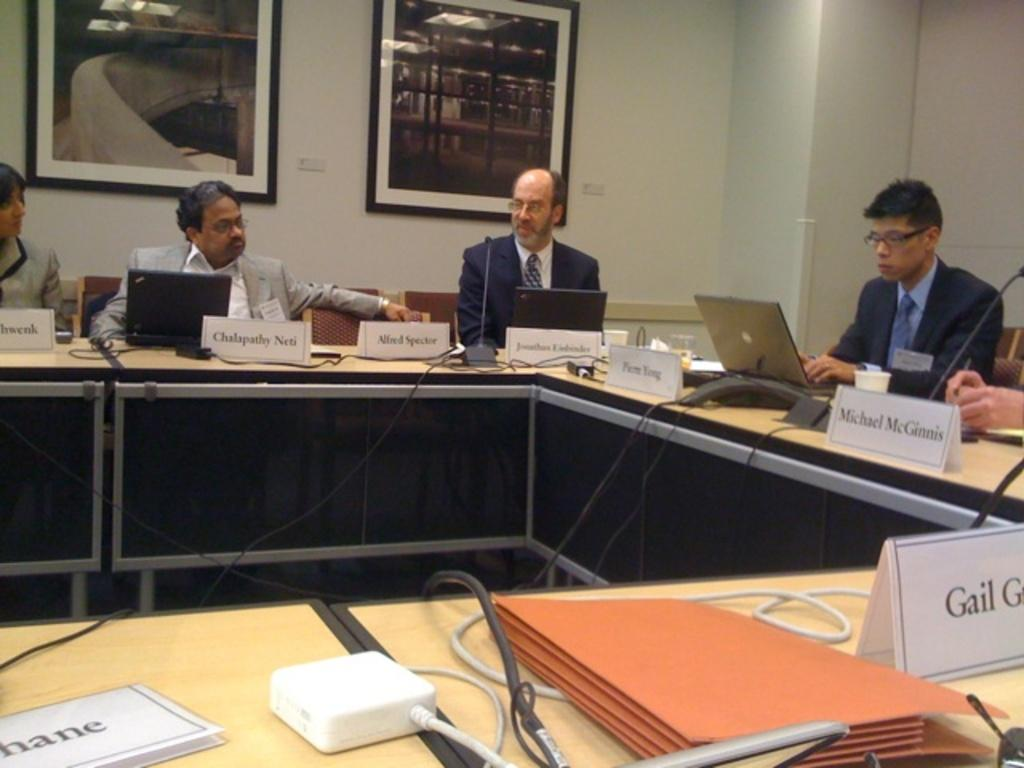Provide a one-sentence caption for the provided image. People in suits, including Michael McGinnis, sit around a U shaped table during a meeting. 